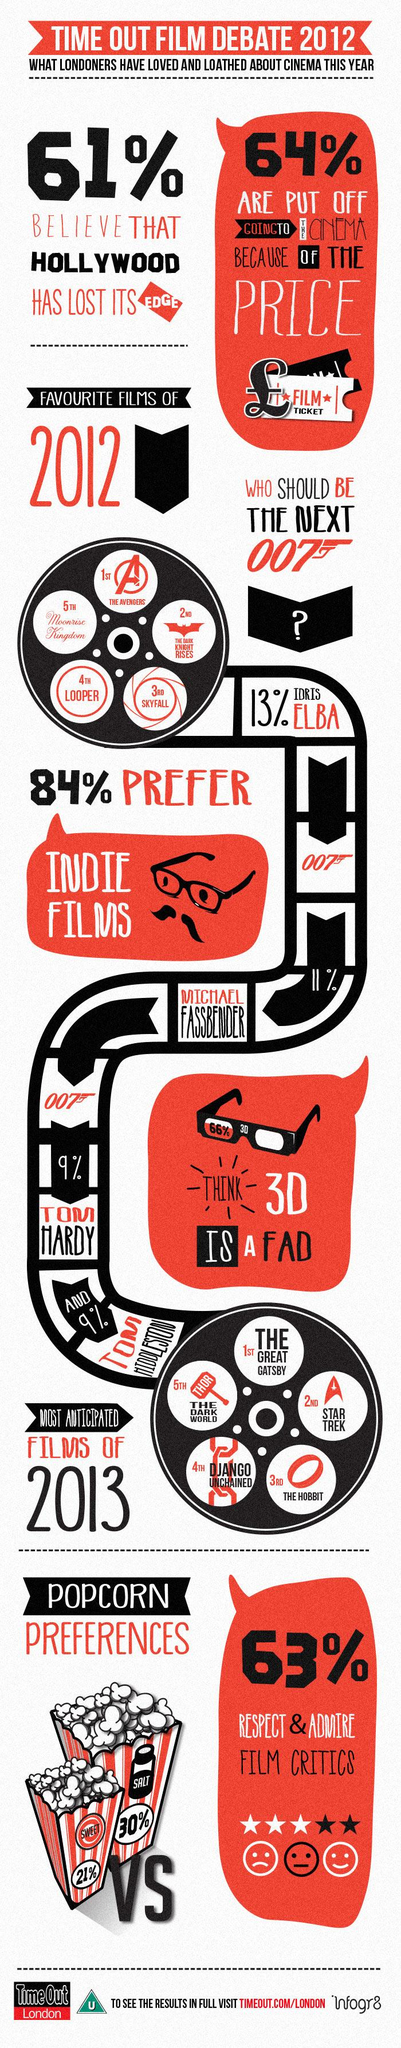Specify some key components in this picture. According to the data, a significant percentage of people do not believe that 3D is a fad, with 34% holding this opinion. THE HOBBIT is the third most highly anticipated film of 2013. Most people prefer the unsalted popcorn shown, as compared to the salted popcorn. A significant percentage of people do not respect and admire film critics, as 37% of the population holds this view. A small minority of people, only 9%, want Tom Hardy to play the next Bond. 